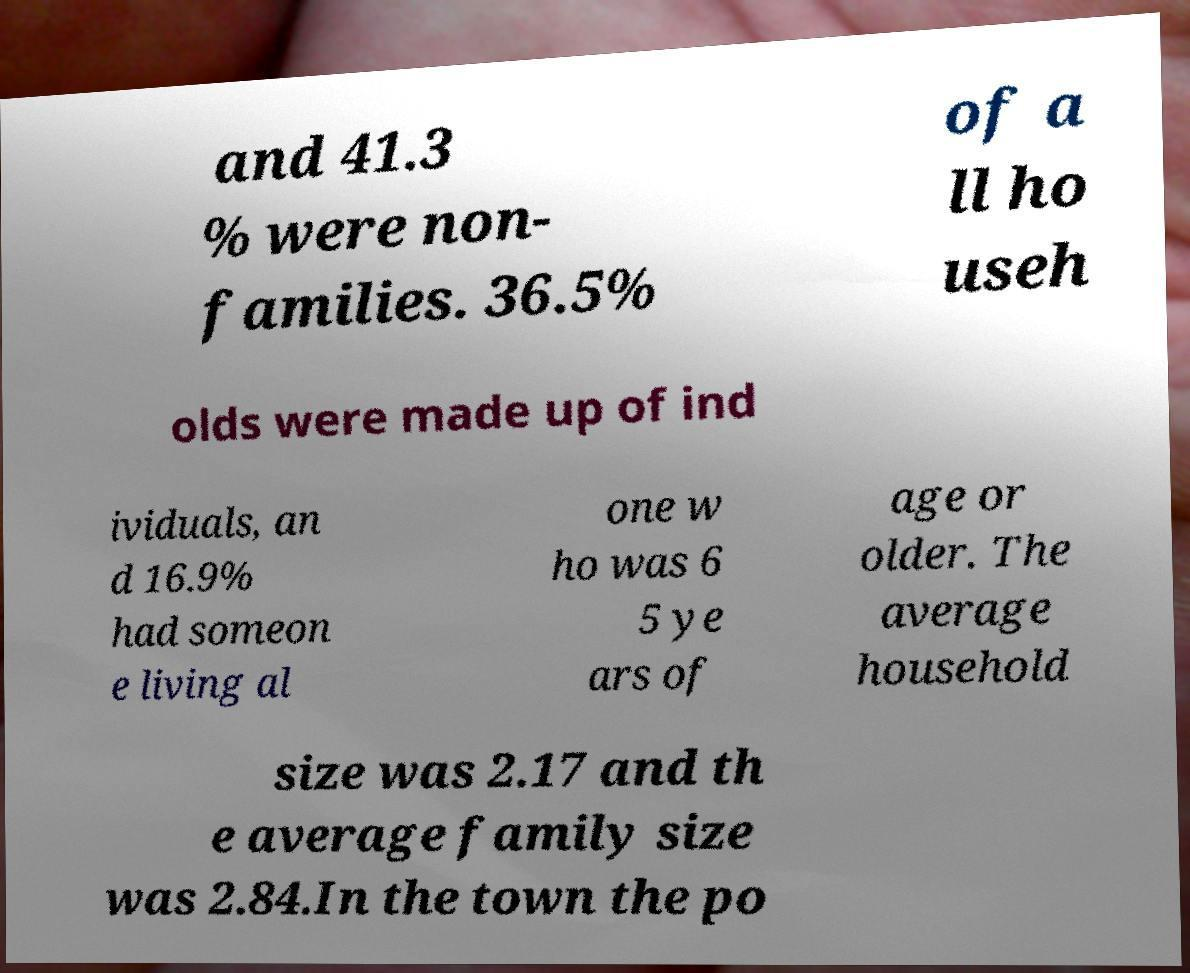For documentation purposes, I need the text within this image transcribed. Could you provide that? and 41.3 % were non- families. 36.5% of a ll ho useh olds were made up of ind ividuals, an d 16.9% had someon e living al one w ho was 6 5 ye ars of age or older. The average household size was 2.17 and th e average family size was 2.84.In the town the po 